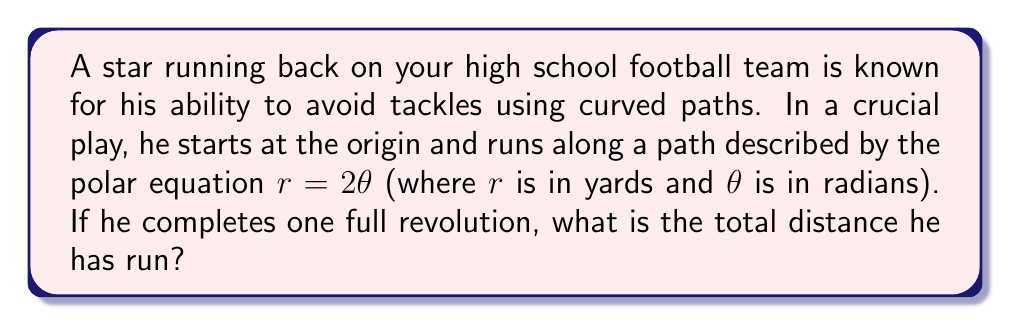Show me your answer to this math problem. Let's approach this step-by-step:

1) The path of the running back is described by the polar equation $r = 2\theta$. This is known as an Archimedean spiral.

2) To find the total distance run, we need to calculate the arc length of this spiral for one complete revolution (i.e., from $\theta = 0$ to $\theta = 2\pi$).

3) The formula for arc length in polar coordinates is:

   $$L = \int_a^b \sqrt{r^2 + \left(\frac{dr}{d\theta}\right)^2} d\theta$$

4) For our equation $r = 2\theta$:
   $\frac{dr}{d\theta} = 2$

5) Substituting into the arc length formula:

   $$L = \int_0^{2\pi} \sqrt{(2\theta)^2 + 2^2} d\theta$$

6) Simplify inside the square root:

   $$L = \int_0^{2\pi} \sqrt{4\theta^2 + 4} d\theta$$
   $$L = 2\int_0^{2\pi} \sqrt{\theta^2 + 1} d\theta$$

7) This integral doesn't have an elementary antiderivative. We can solve it using the substitution $\theta = \sinh u$:

   $$L = 2\int_0^{\sinh^{-1}(2\pi)} \sqrt{\sinh^2 u + 1} \cosh u du$$

8) Using the identity $\sinh^2 u + 1 = \cosh^2 u$:

   $$L = 2\int_0^{\sinh^{-1}(2\pi)} \cosh^2 u du$$

9) This integrates to:

   $$L = 2\left[\frac{u}{2} + \frac{\sinh(2u)}{4}\right]_0^{\sinh^{-1}(2\pi)}$$

10) Evaluating the limits:

    $$L = 2\left[\frac{\sinh^{-1}(2\pi)}{2} + \frac{\sinh(2\sinh^{-1}(2\pi))}{4}\right]$$

11) Simplify using hyperbolic function identities:

    $$L = \sinh^{-1}(2\pi) + \frac{\pi\sqrt{4\pi^2+1}}{2}$$

12) This gives us the exact answer in yards. To get a numerical approximation:

    $$L \approx 20.66 \text{ yards}$$
Answer: The total distance run by the running back is $\sinh^{-1}(2\pi) + \frac{\pi\sqrt{4\pi^2+1}}{2}$ yards, which is approximately 20.66 yards. 